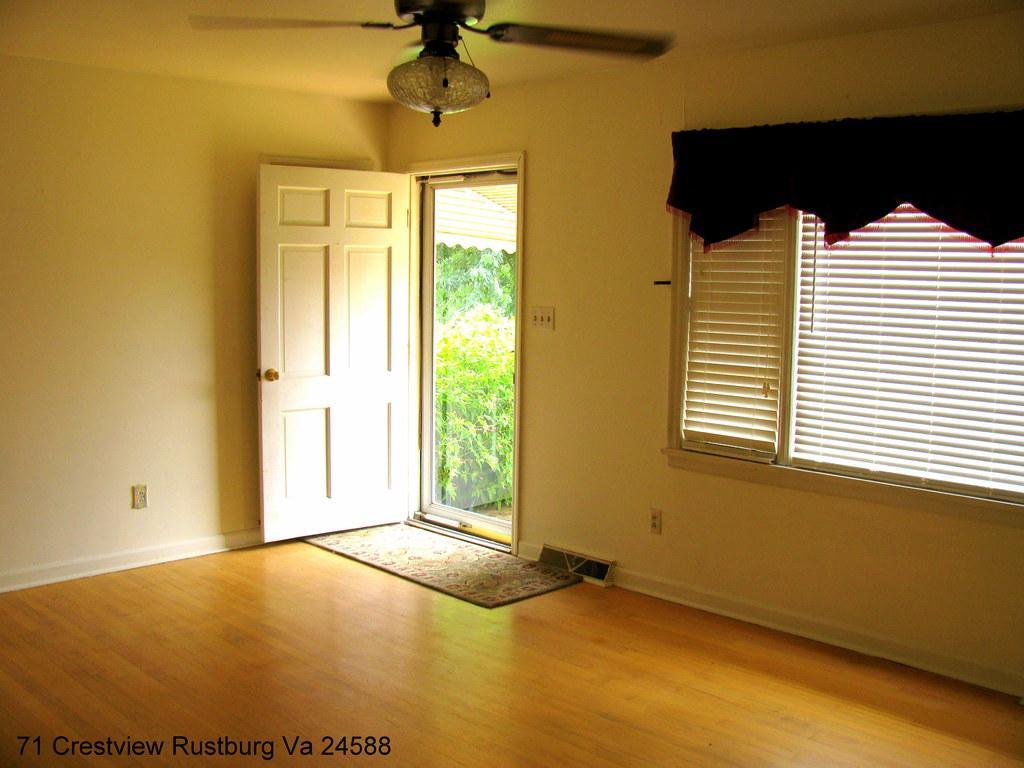Can you describe this image briefly? In this image I can see a wall, window, curtain, door, fan, doormat, text, plants and trees. This image is taken may be in a hall. 